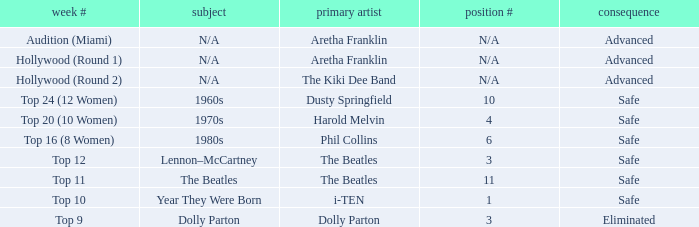What is the order number that has top 20 (10 women)  as the week number? 4.0. 